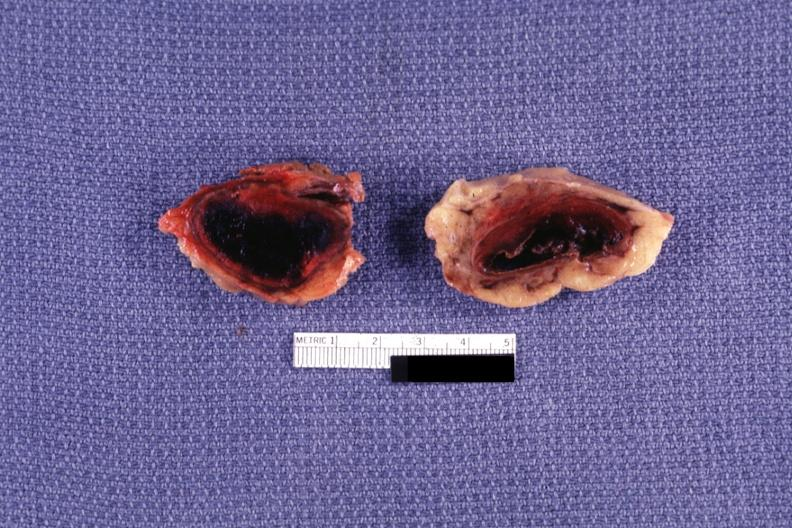s endocrine present?
Answer the question using a single word or phrase. Yes 